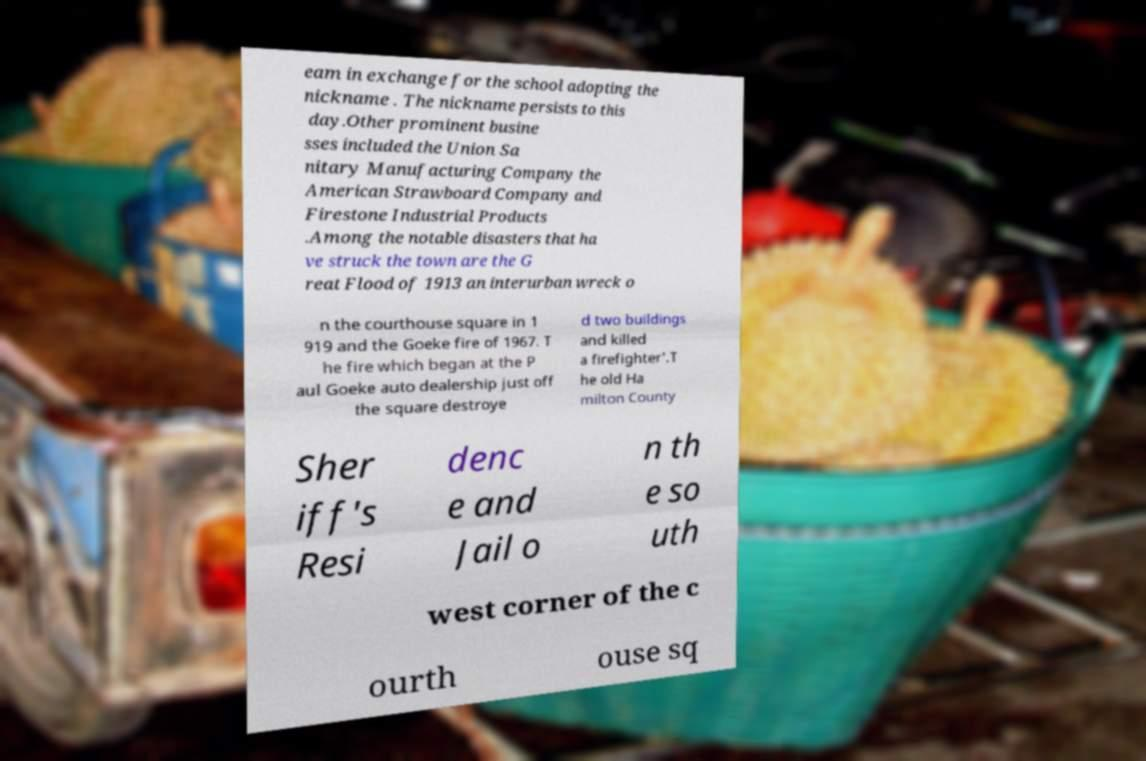Could you extract and type out the text from this image? eam in exchange for the school adopting the nickname . The nickname persists to this day.Other prominent busine sses included the Union Sa nitary Manufacturing Company the American Strawboard Company and Firestone Industrial Products .Among the notable disasters that ha ve struck the town are the G reat Flood of 1913 an interurban wreck o n the courthouse square in 1 919 and the Goeke fire of 1967. T he fire which began at the P aul Goeke auto dealership just off the square destroye d two buildings and killed a firefighter'.T he old Ha milton County Sher iff's Resi denc e and Jail o n th e so uth west corner of the c ourth ouse sq 